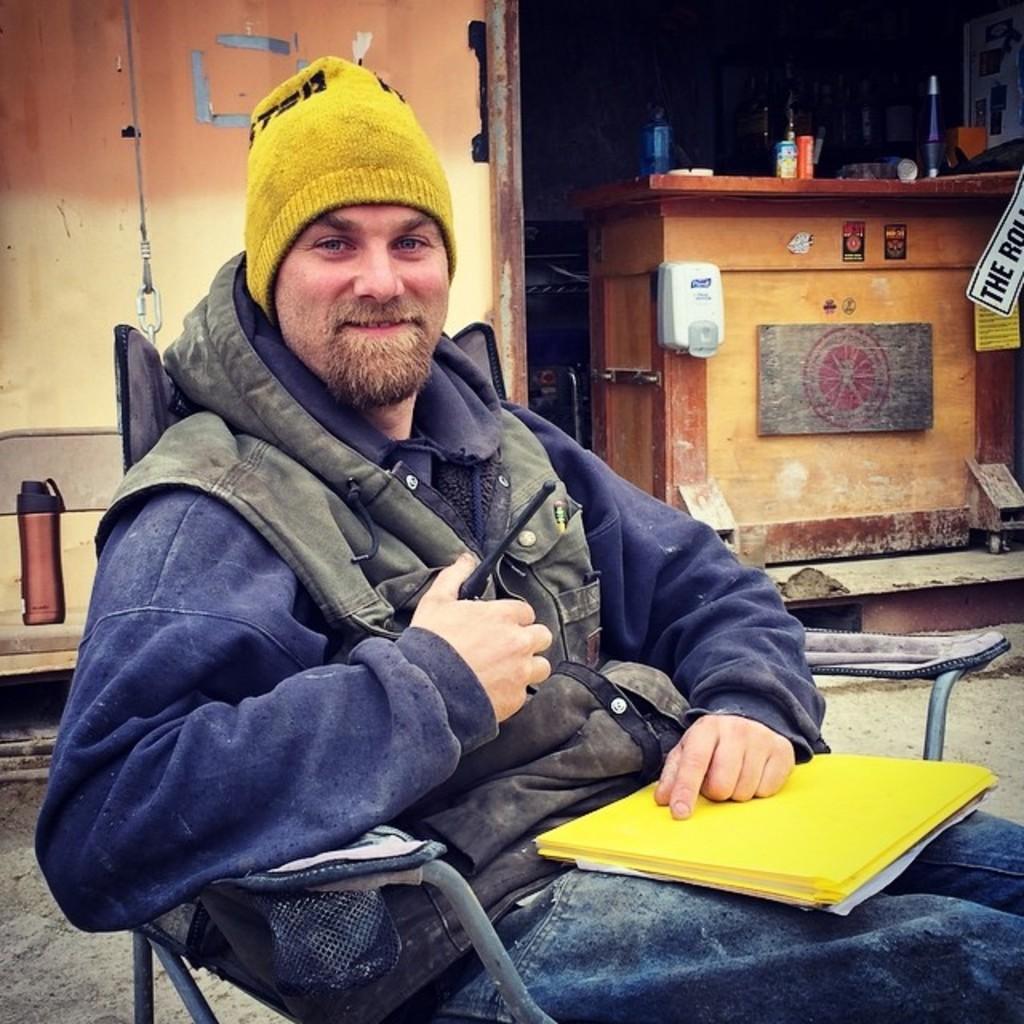Describe this image in one or two sentences. In the picture I can see a person wearing jacket and a cap is sitting on the chair and there are yellow color files on him. In the background, I can see bottle, wooden table on which few things are kept. 